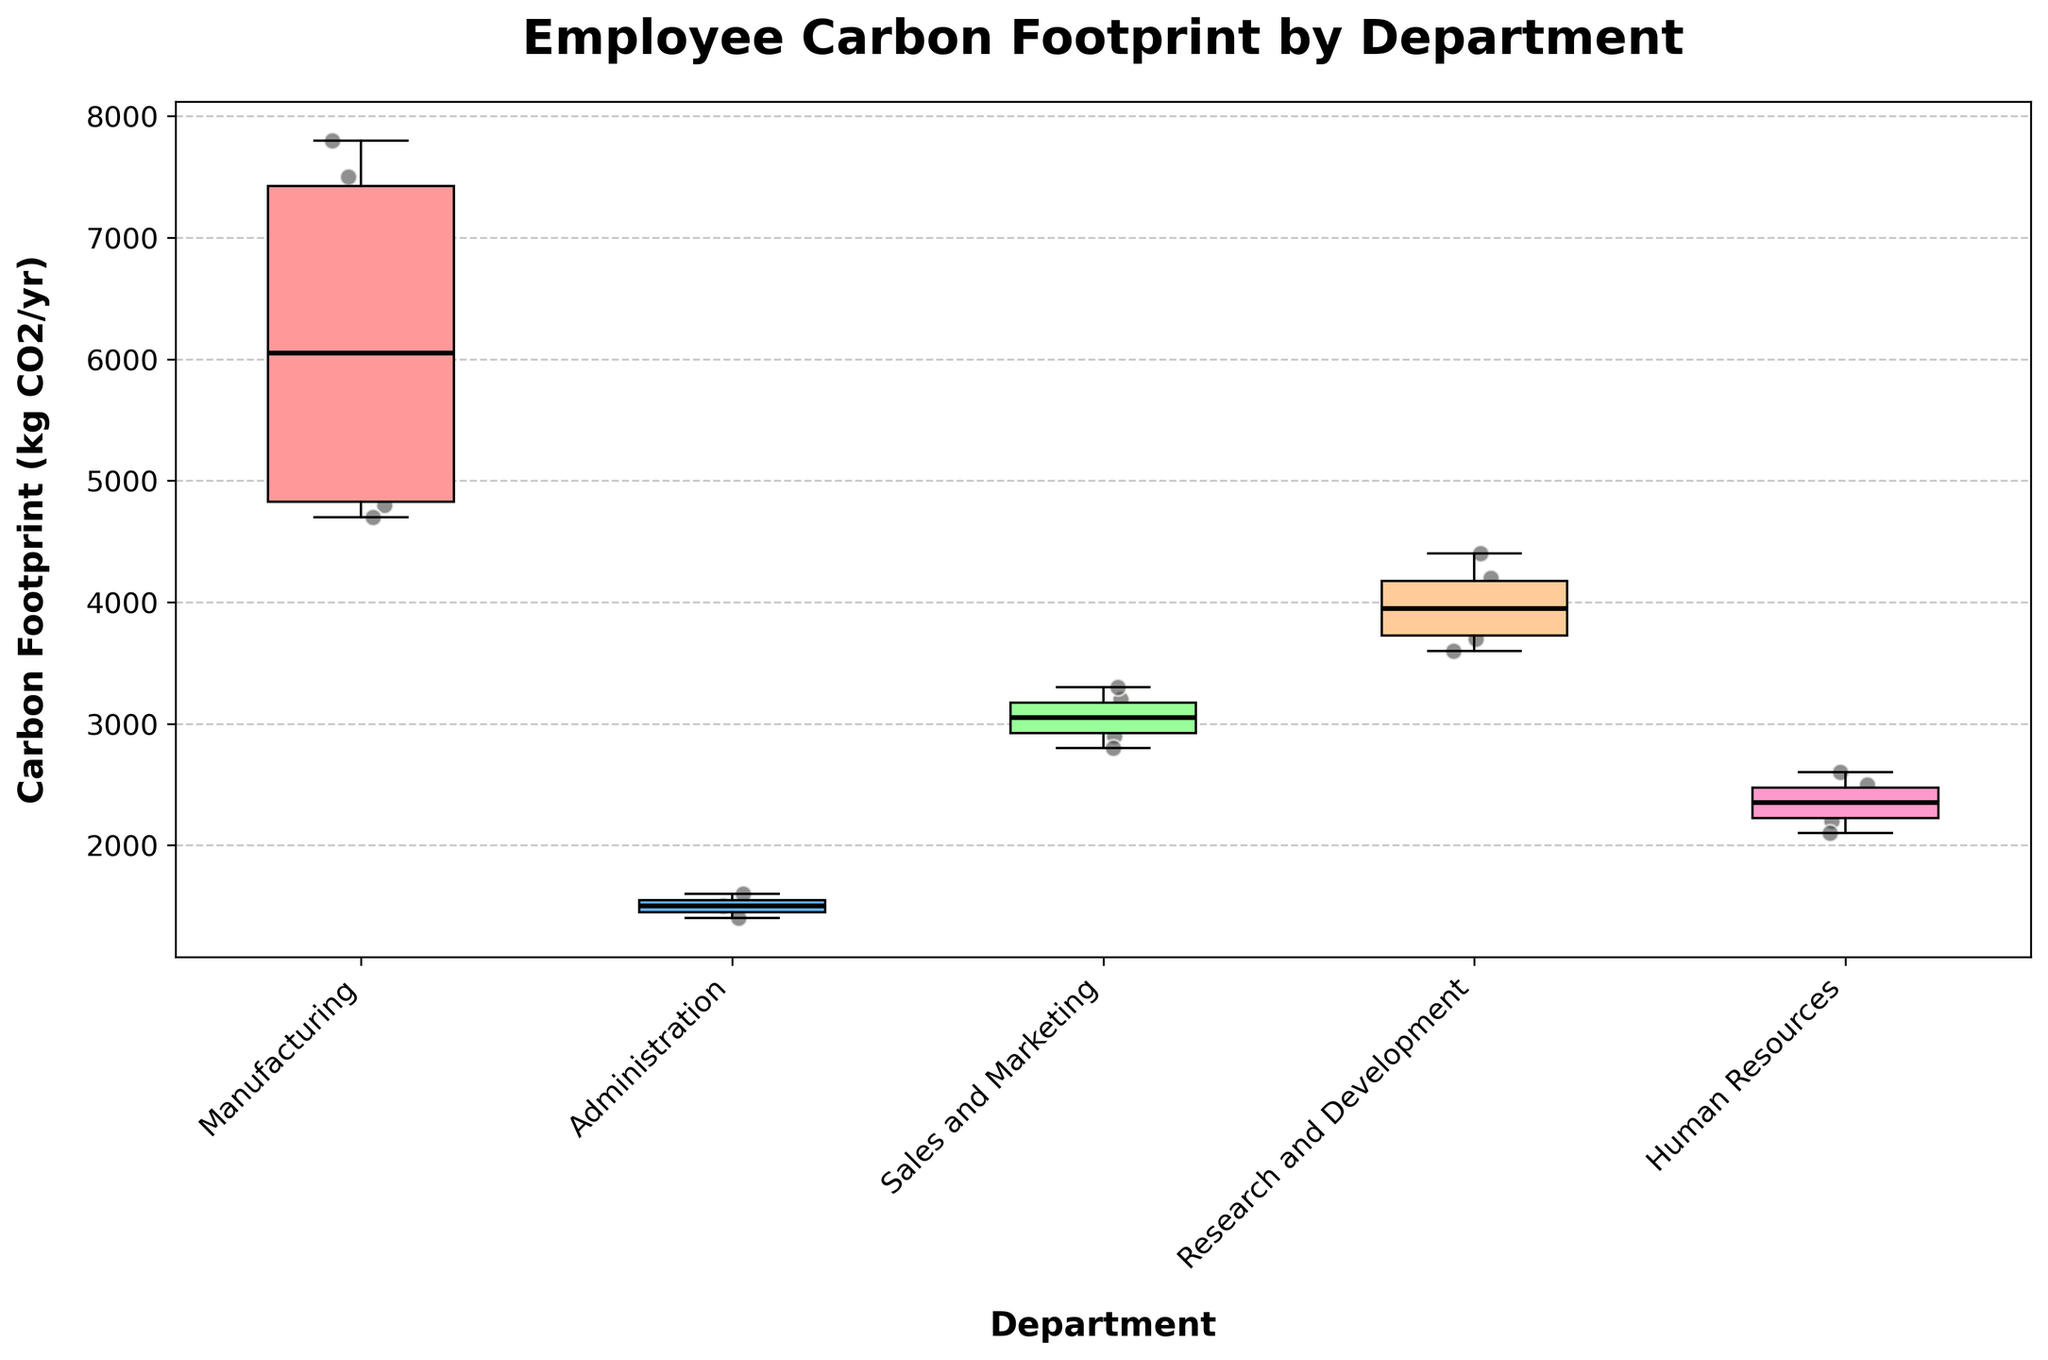What is the title of the plot? The title of the plot is usually placed at the top of the figure and is intended to summarize the main topic of the visualization. Here, the title is clearly displayed at the top.
Answer: Employee Carbon Footprint by Department How many departments are represented in the plot? The number of departments can be counted by looking at the x-axis where each department's name is listed.
Answer: 5 Which department has the highest median carbon footprint? To identify the department with the highest median carbon footprint, compare the horizontal lines in the center of each box, which represent the median values.
Answer: Manufacturing Which department has the lowest median carbon footprint? To identify the lowest median carbon footprint, look for the department whose box plot has the lowest central horizontal line.
Answer: Administration What is the approximate median carbon footprint for the Sales and Marketing department? The median is represented by the central horizontal line in the box plot for the Sales and Marketing department. Each tick on the y-axis represents a step, so estimate the value by summarizing the vertical position.
Answer: Approximately 3,000 kg CO2/yr Which role within the Human Resources department seems to have a smaller carbon footprint, HR Manager or Recruiter? Compare the scatter points for HR Manager and Recruiter within the Human Resources department. The overall position of the points will indicate which role has a smaller footprint.
Answer: Recruiter By how much does the median carbon footprint of the Manufacturing department exceed that of the Administration department? Determine the median values for both departments by comparing the central lines in their respective boxes, then subtract the Administration's median from Manufacturing's median.
Answer: Approximately 6,000 kg CO2/yr Which department exhibits the widest interquartile range (IQR) for carbon footprints? The IQR is given by the length of the box in the box plot. Identify the department with the widest box.
Answer: Manufacturing Are there any outliers in the dataset as represented in the plot? Outliers in a box plot are typically shown as individual points at a significant distance from the rest of the data. Check if there are any such points.
Answer: No What does the position of the scatter points within each box plot indicate? Scatter points show the distribution of individual data points, giving an idea of the variation and density of data within each department. The closer the points, the more consistent the carbon footprints.
Answer: Distribution within departments 